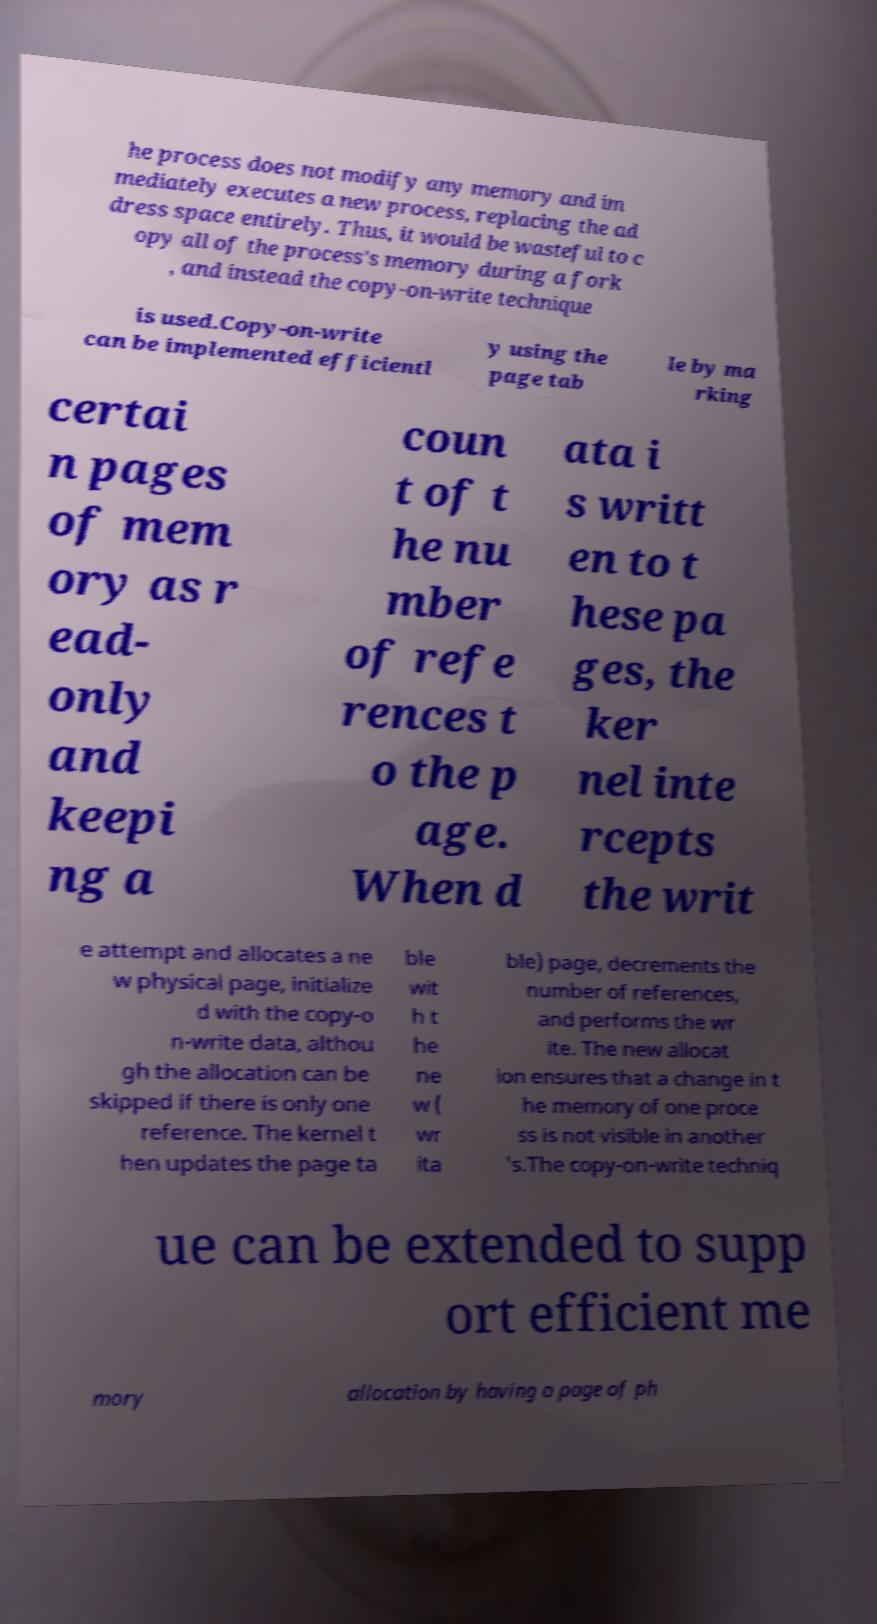What messages or text are displayed in this image? I need them in a readable, typed format. he process does not modify any memory and im mediately executes a new process, replacing the ad dress space entirely. Thus, it would be wasteful to c opy all of the process's memory during a fork , and instead the copy-on-write technique is used.Copy-on-write can be implemented efficientl y using the page tab le by ma rking certai n pages of mem ory as r ead- only and keepi ng a coun t of t he nu mber of refe rences t o the p age. When d ata i s writt en to t hese pa ges, the ker nel inte rcepts the writ e attempt and allocates a ne w physical page, initialize d with the copy-o n-write data, althou gh the allocation can be skipped if there is only one reference. The kernel t hen updates the page ta ble wit h t he ne w ( wr ita ble) page, decrements the number of references, and performs the wr ite. The new allocat ion ensures that a change in t he memory of one proce ss is not visible in another 's.The copy-on-write techniq ue can be extended to supp ort efficient me mory allocation by having a page of ph 